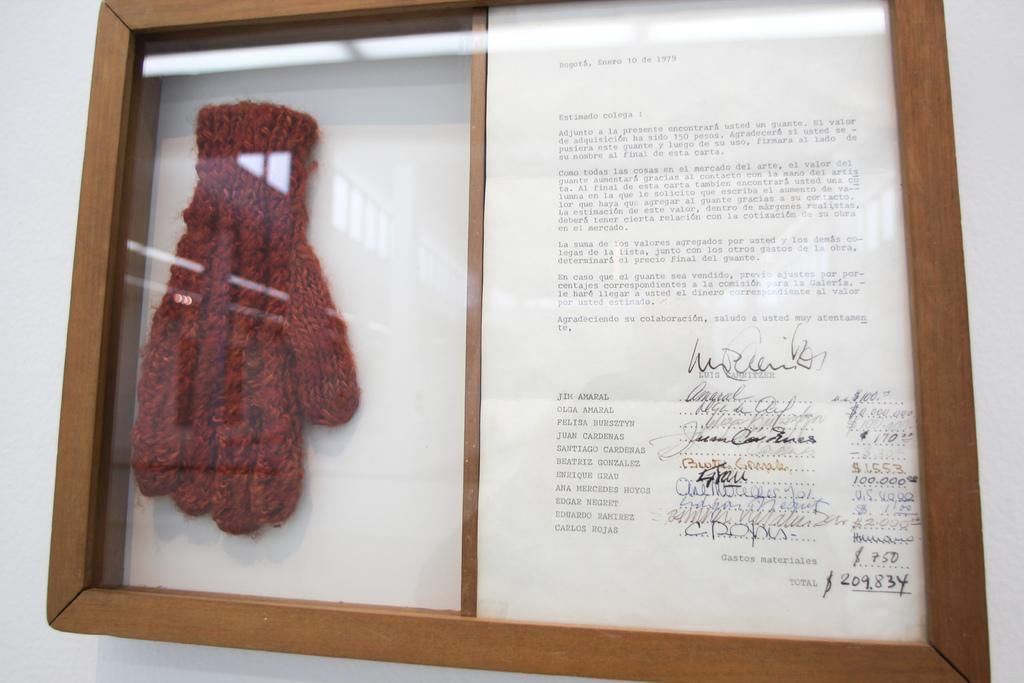What can be seen on the wall in the image? There is a frame on the wall in the image. What is inside the frame? There is a letter and a glove inside the frame. What type of produce is hanging from the ceiling in the image? There is no produce visible in the image; it only features a wall, a frame, a letter, and a glove. 